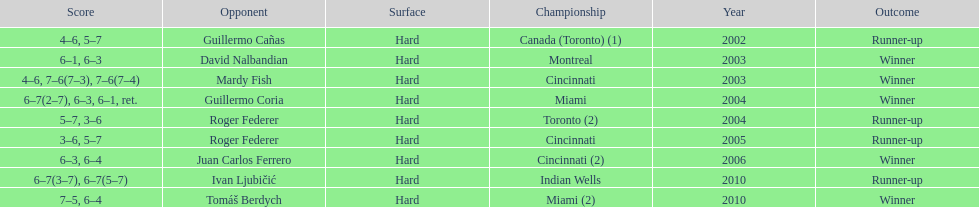How many occasions was the championship in miami? 2. 